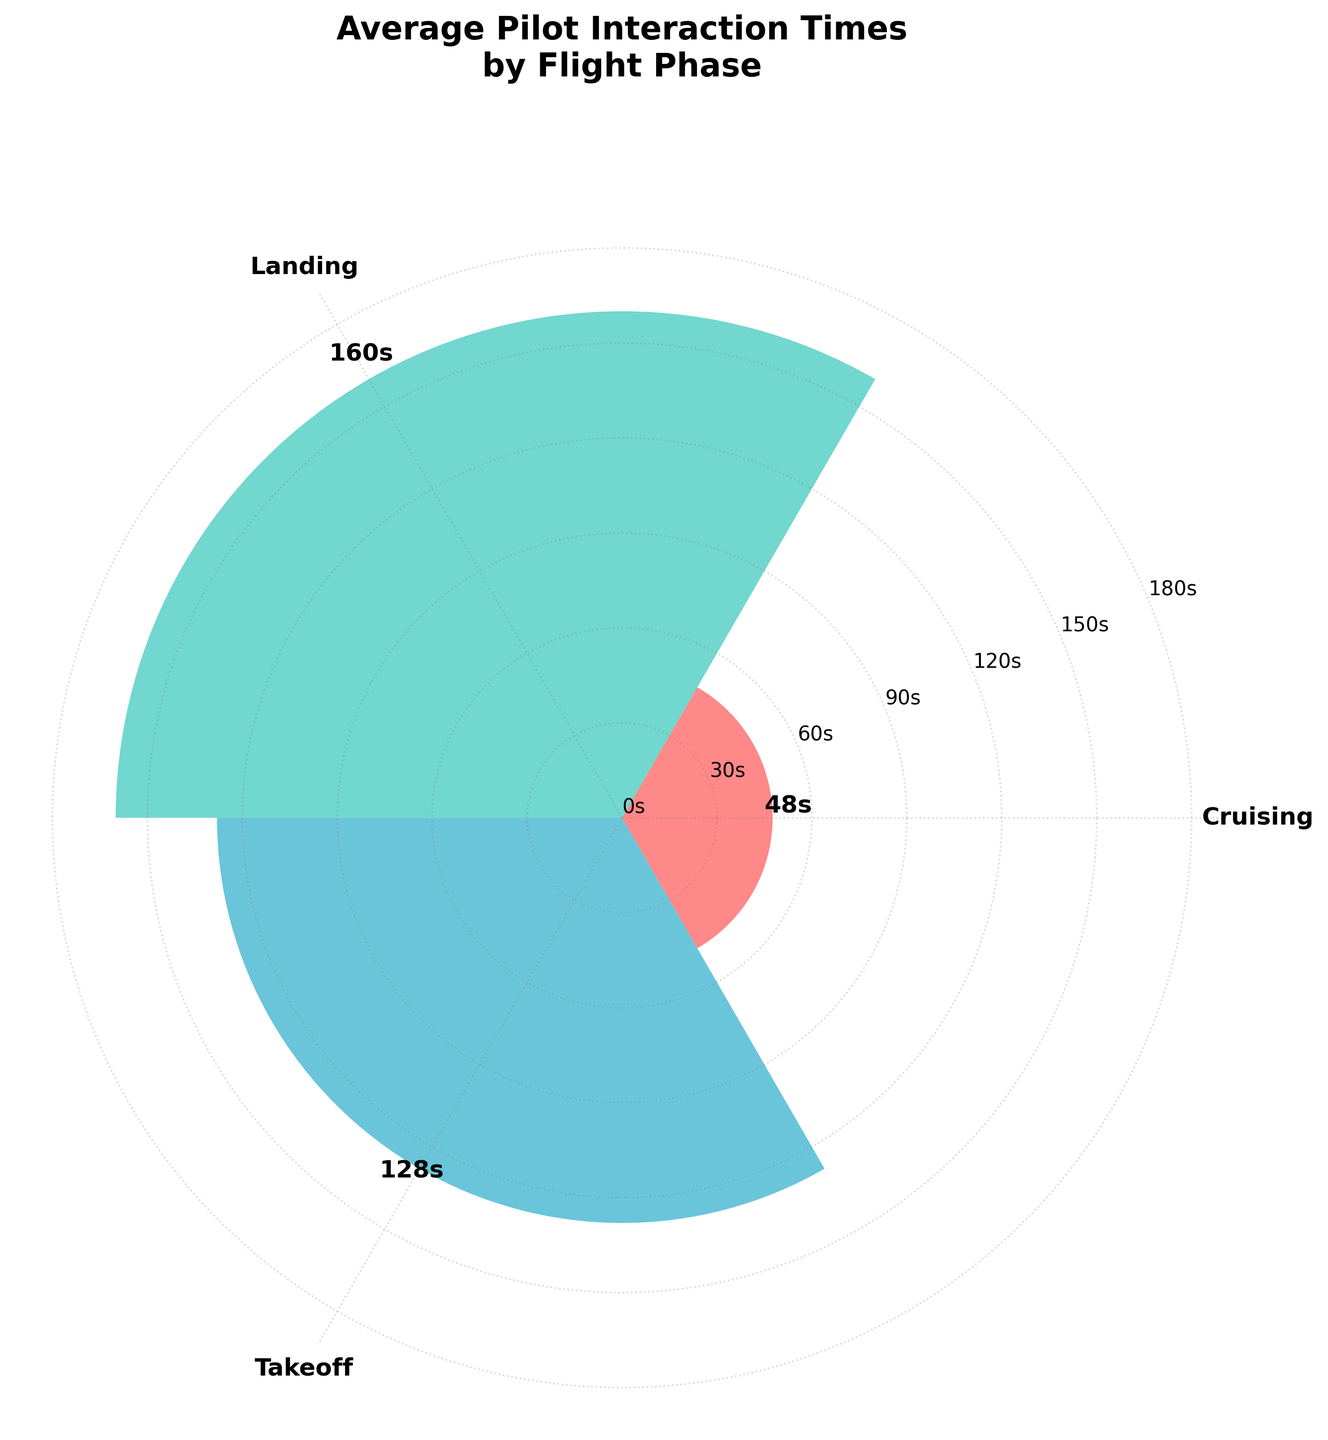What is the title of the figure? The title of the figure is located at the top of the plot. By reading it, we can determine that it is "Average Pilot Interaction Times by Flight Phase."
Answer: Average Pilot Interaction Times by Flight Phase Which phase of flight has the highest average interaction time? By examining the length of the bars in the rose chart, we can see that the phase labeled "Landing" has the highest value.
Answer: Landing What is the average interaction time during the takeoff phase? The bar corresponding to the "Takeoff" phase has an annotated value above it. It reads 128 seconds.
Answer: 128s How many phases of flight are represented in the chart? There are three distinct bars in the chart, each representing a different phase of flight.
Answer: 3 Which phase has the shortest average interaction time? By comparing the heights of the bars, the "Cruising" phase has the shortest average interaction time.
Answer: Cruising By how many seconds does the average interaction time in the landing phase exceed that in the cruising phase? The average interaction time in the landing phase is 160 seconds, and in the cruising phase, it is 48 seconds. Subtracting these two values gives 112 seconds (160 - 48).
Answer: 112s What is the approximate sum of the average interaction times across all phases of flight? Summing up the average interaction times for all phases: Takeoff (128s) + Cruising (48s) + Landing (160s) equals 336 seconds.
Answer: 336s By what ratio is the average interaction time during landing greater than during cruising? Dividing the average interaction time during landing (160s) by the average time during cruising (48s) gives 3.33.
Answer: 3.33 How does the width of bars in the chart contribute to understanding the plot? The width of the bars is uniform and not related to the data values, which helps focus attention solely on the radius and height to determine the average interaction times.
Answer: Uniform width What visual elements indicate the exact average interaction times for each phase? The exact average interaction times are annotated above each bar in the chart, providing precise numerical values.
Answer: Annotated values above bars 